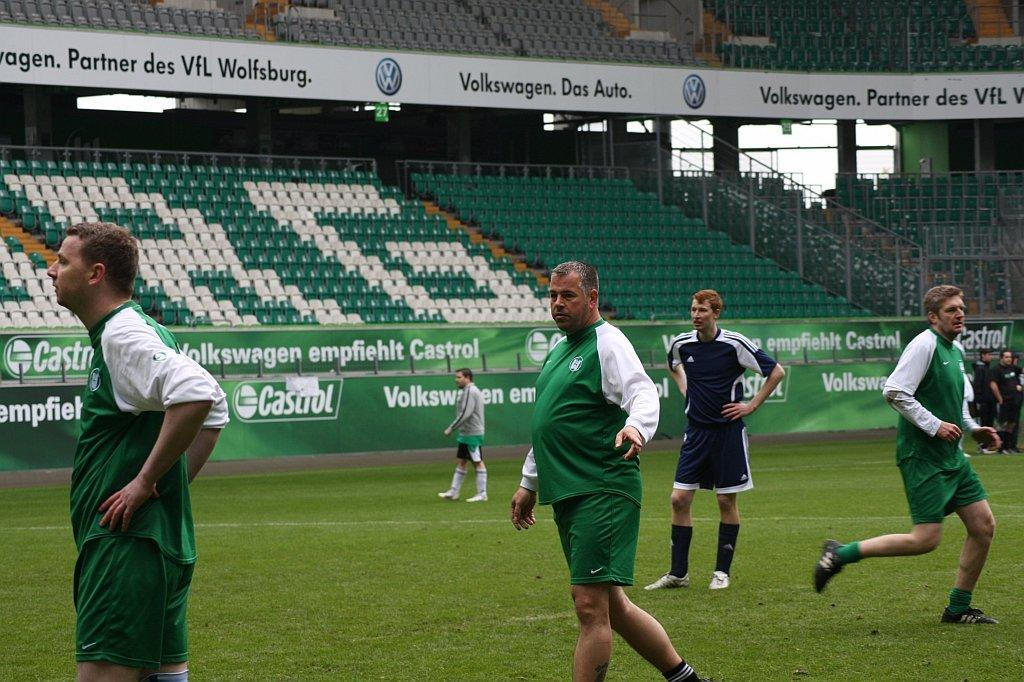How many people are in the image? There are two persons in the image. What is the setting of the image? The persons are standing on a greenery ground. What can be seen in the background of the image? There are banners and empty chairs in the background of the image. What type of wine is being served at the event depicted in the image? There is no indication of any wine or event in the image. 